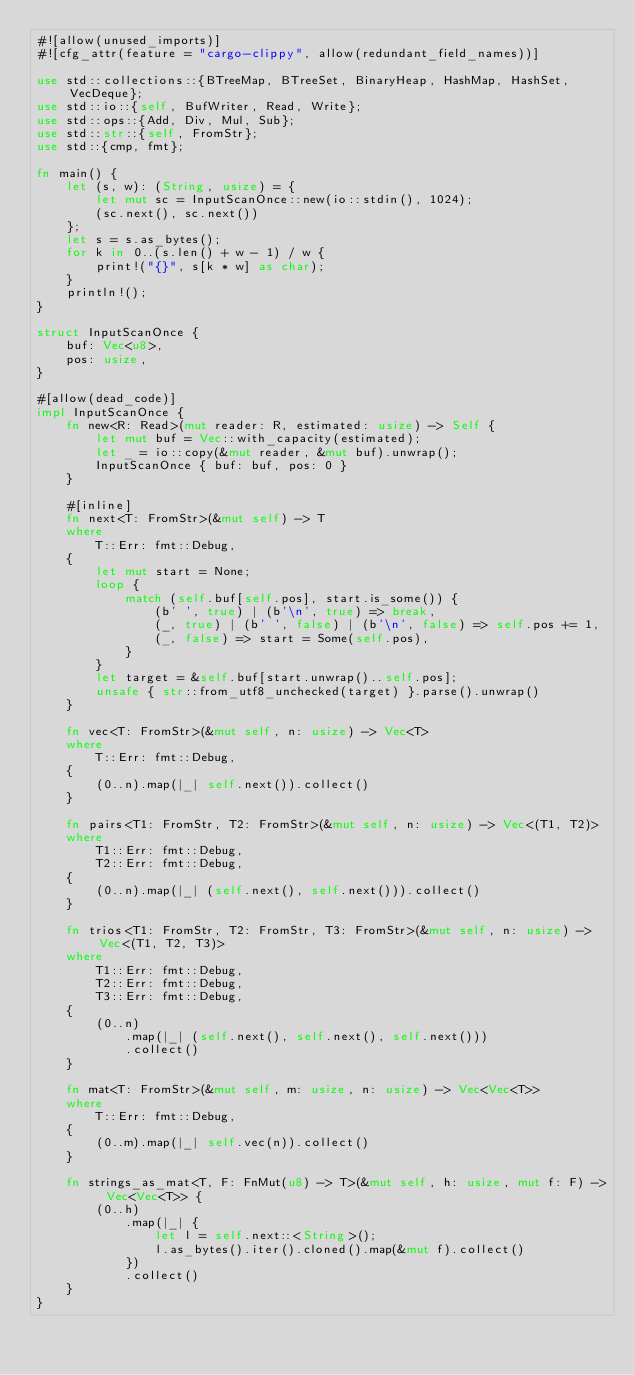Convert code to text. <code><loc_0><loc_0><loc_500><loc_500><_Rust_>#![allow(unused_imports)]
#![cfg_attr(feature = "cargo-clippy", allow(redundant_field_names))]

use std::collections::{BTreeMap, BTreeSet, BinaryHeap, HashMap, HashSet, VecDeque};
use std::io::{self, BufWriter, Read, Write};
use std::ops::{Add, Div, Mul, Sub};
use std::str::{self, FromStr};
use std::{cmp, fmt};

fn main() {
    let (s, w): (String, usize) = {
        let mut sc = InputScanOnce::new(io::stdin(), 1024);
        (sc.next(), sc.next())
    };
    let s = s.as_bytes();
    for k in 0..(s.len() + w - 1) / w {
        print!("{}", s[k * w] as char);
    }
    println!();
}

struct InputScanOnce {
    buf: Vec<u8>,
    pos: usize,
}

#[allow(dead_code)]
impl InputScanOnce {
    fn new<R: Read>(mut reader: R, estimated: usize) -> Self {
        let mut buf = Vec::with_capacity(estimated);
        let _ = io::copy(&mut reader, &mut buf).unwrap();
        InputScanOnce { buf: buf, pos: 0 }
    }

    #[inline]
    fn next<T: FromStr>(&mut self) -> T
    where
        T::Err: fmt::Debug,
    {
        let mut start = None;
        loop {
            match (self.buf[self.pos], start.is_some()) {
                (b' ', true) | (b'\n', true) => break,
                (_, true) | (b' ', false) | (b'\n', false) => self.pos += 1,
                (_, false) => start = Some(self.pos),
            }
        }
        let target = &self.buf[start.unwrap()..self.pos];
        unsafe { str::from_utf8_unchecked(target) }.parse().unwrap()
    }

    fn vec<T: FromStr>(&mut self, n: usize) -> Vec<T>
    where
        T::Err: fmt::Debug,
    {
        (0..n).map(|_| self.next()).collect()
    }

    fn pairs<T1: FromStr, T2: FromStr>(&mut self, n: usize) -> Vec<(T1, T2)>
    where
        T1::Err: fmt::Debug,
        T2::Err: fmt::Debug,
    {
        (0..n).map(|_| (self.next(), self.next())).collect()
    }

    fn trios<T1: FromStr, T2: FromStr, T3: FromStr>(&mut self, n: usize) -> Vec<(T1, T2, T3)>
    where
        T1::Err: fmt::Debug,
        T2::Err: fmt::Debug,
        T3::Err: fmt::Debug,
    {
        (0..n)
            .map(|_| (self.next(), self.next(), self.next()))
            .collect()
    }

    fn mat<T: FromStr>(&mut self, m: usize, n: usize) -> Vec<Vec<T>>
    where
        T::Err: fmt::Debug,
    {
        (0..m).map(|_| self.vec(n)).collect()
    }

    fn strings_as_mat<T, F: FnMut(u8) -> T>(&mut self, h: usize, mut f: F) -> Vec<Vec<T>> {
        (0..h)
            .map(|_| {
                let l = self.next::<String>();
                l.as_bytes().iter().cloned().map(&mut f).collect()
            })
            .collect()
    }
}
</code> 